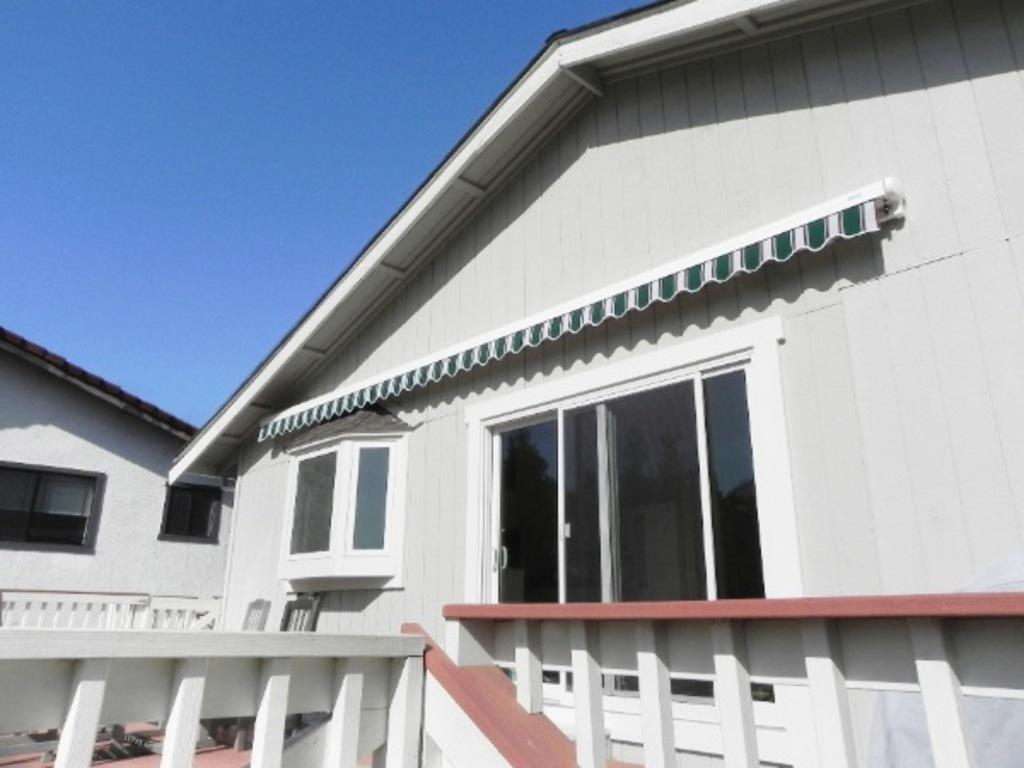What type of structures are present in the image? There are buildings in the image. What feature can be seen on the buildings? The buildings have windows. What is visible in the background of the image? The sky is visible in the background of the image. How would you describe the sky in the image? The sky is clear in the image. How does the ink flow from the pen in the image? There is no pen or ink present in the image; it features buildings with windows and a clear sky in the background. 